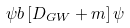Convert formula to latex. <formula><loc_0><loc_0><loc_500><loc_500>\psi b \left [ D _ { G W } + m \right ] \psi</formula> 